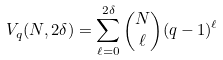<formula> <loc_0><loc_0><loc_500><loc_500>V _ { q } ( N , 2 \delta ) = \sum _ { \ell = 0 } ^ { 2 \delta } { N \choose \ell } ( q - 1 ) ^ { \ell }</formula> 